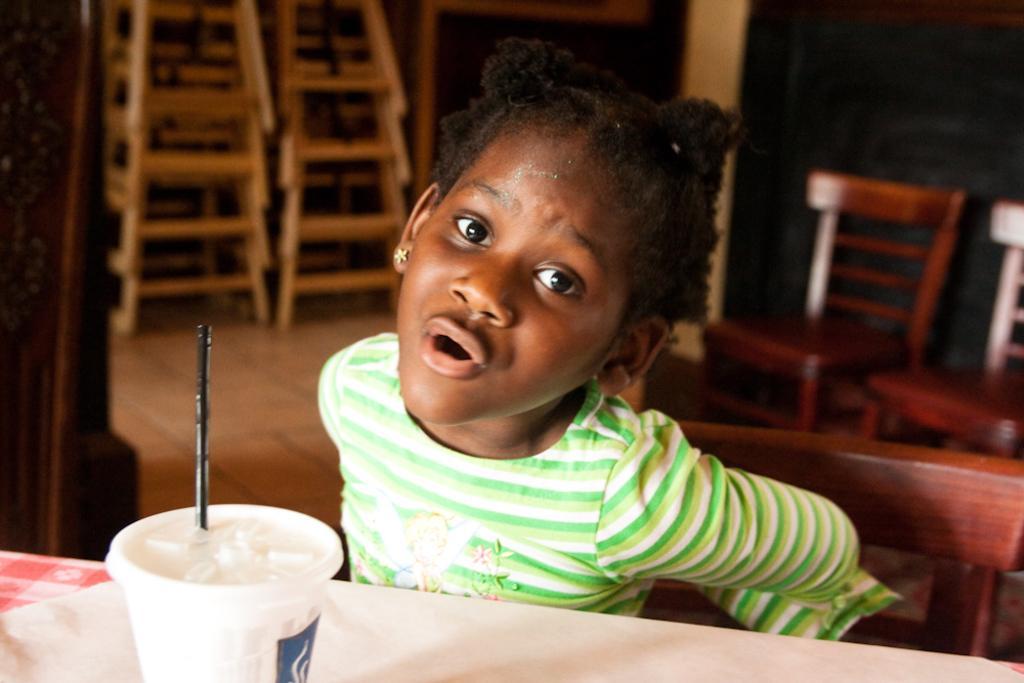How would you summarize this image in a sentence or two? In this picture we can find a child sitting on a chair near the table. On that table \we can find a glass and straw with some drink, background we can find some chairs and stand. 